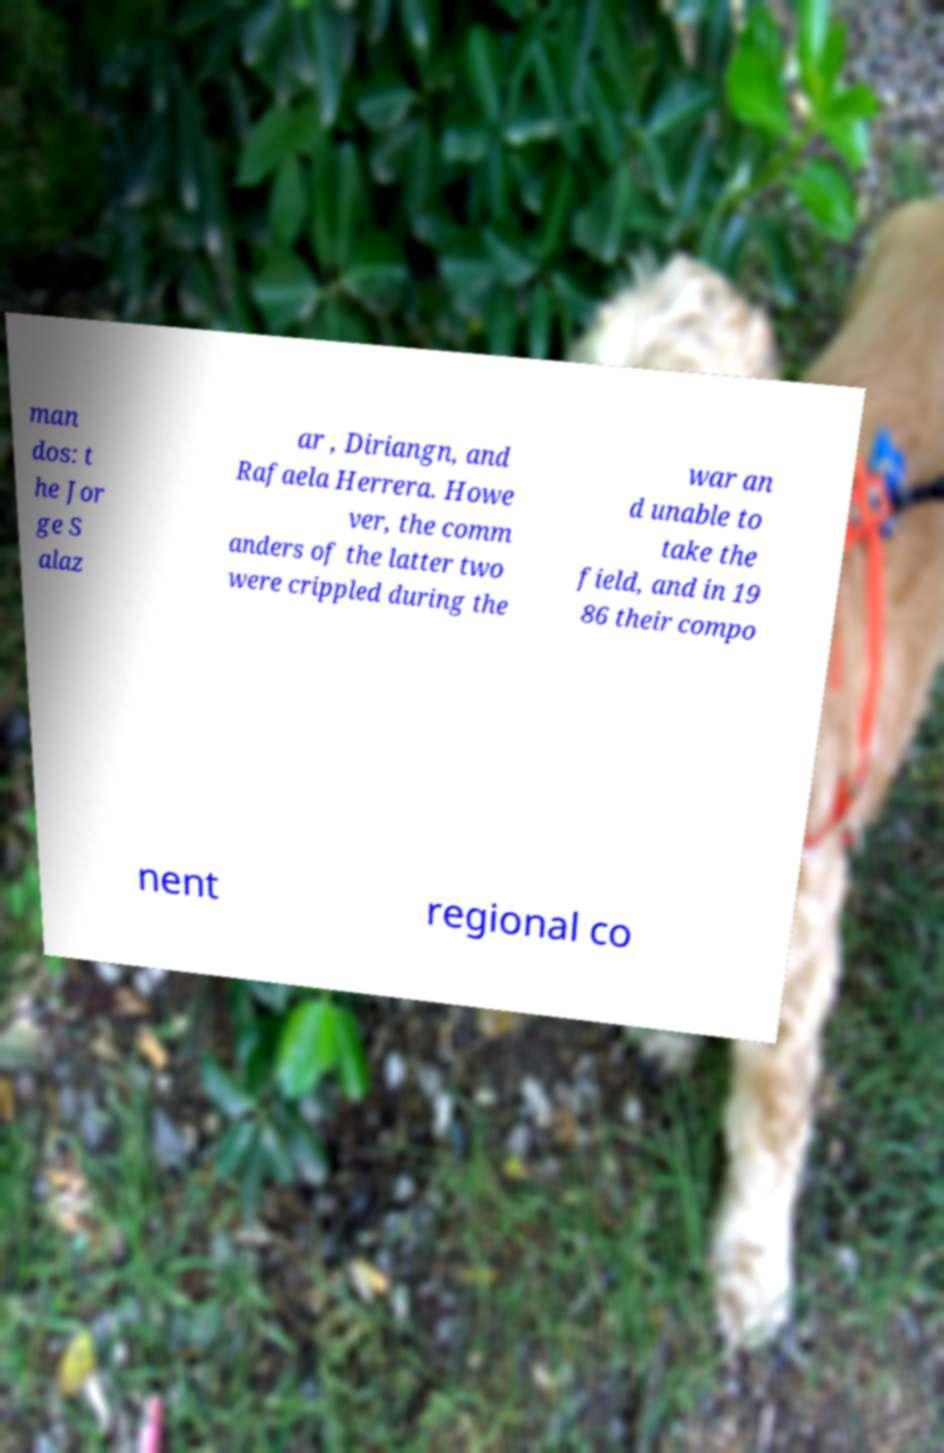Please identify and transcribe the text found in this image. man dos: t he Jor ge S alaz ar , Diriangn, and Rafaela Herrera. Howe ver, the comm anders of the latter two were crippled during the war an d unable to take the field, and in 19 86 their compo nent regional co 